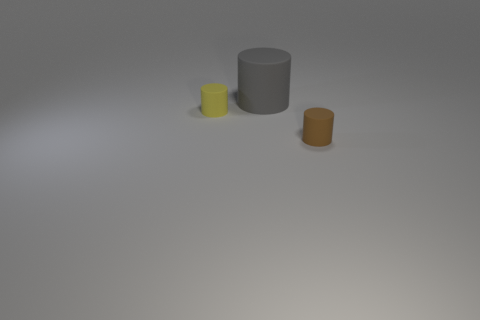Add 2 brown rubber spheres. How many objects exist? 5 Add 1 yellow rubber cylinders. How many yellow rubber cylinders are left? 2 Add 3 gray things. How many gray things exist? 4 Subtract 0 green cylinders. How many objects are left? 3 Subtract all big green cylinders. Subtract all yellow matte things. How many objects are left? 2 